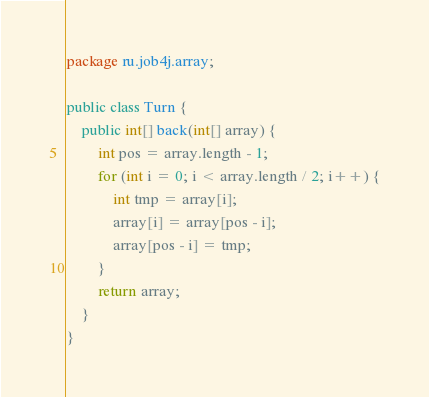<code> <loc_0><loc_0><loc_500><loc_500><_Java_>package ru.job4j.array;

public class Turn {
    public int[] back(int[] array) {
        int pos = array.length - 1;
        for (int i = 0; i < array.length / 2; i++) {
            int tmp = array[i];
            array[i] = array[pos - i];
            array[pos - i] = tmp;
        }
        return array;
    }
}</code> 